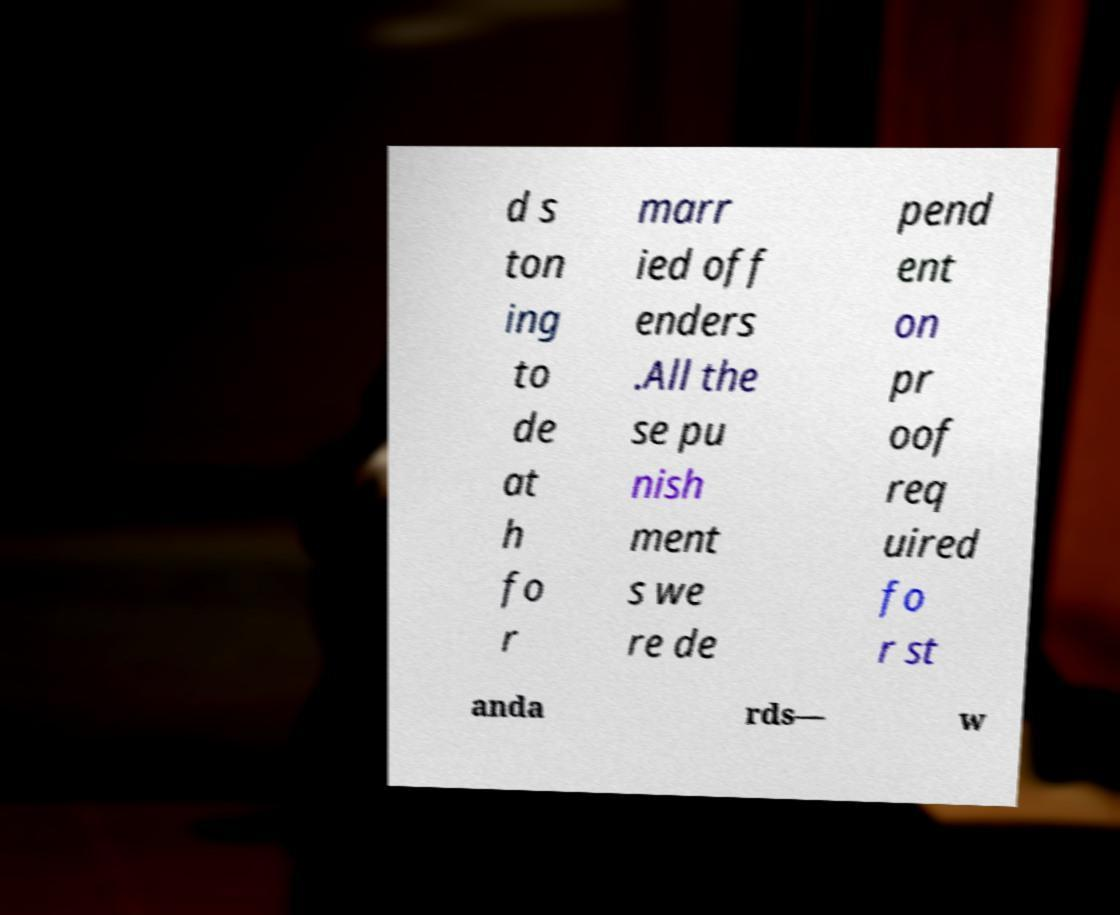There's text embedded in this image that I need extracted. Can you transcribe it verbatim? d s ton ing to de at h fo r marr ied off enders .All the se pu nish ment s we re de pend ent on pr oof req uired fo r st anda rds— w 